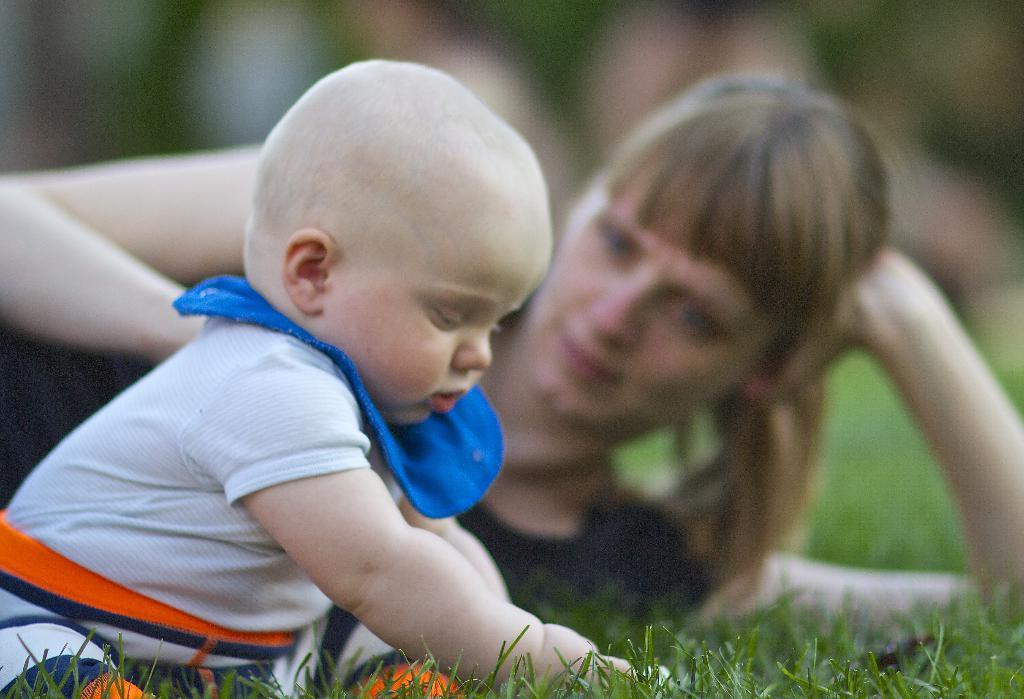What is the main subject of the image? There is a kid in the image. Can you describe the person behind the kid? The person behind the kid is not clearly visible due to the blurred background. What type of terrain is visible at the bottom of the image? There is grass at the bottom of the image. How would you describe the overall appearance of the background in the image? The background of the image is blurred. What type of fowl can be seen in the image? There is no fowl present in the image. What is the cause of the blurred background in the image? The cause of the blurred background is not mentioned in the provided facts, so it cannot be determined from the image alone. 